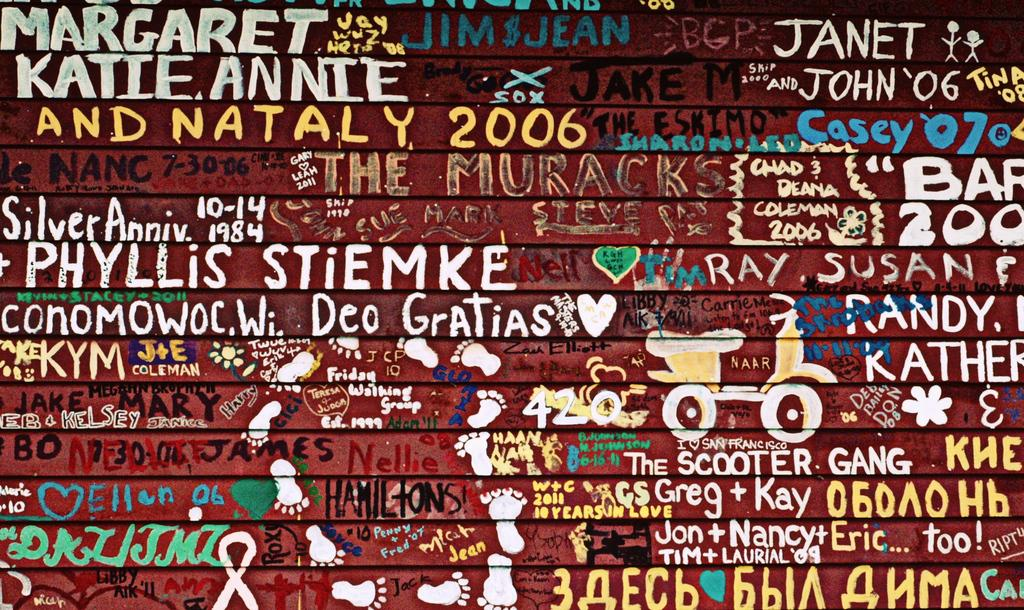<image>
Provide a brief description of the given image. A wall where visitors write their names, some include Margaret, Katie and Annie. 